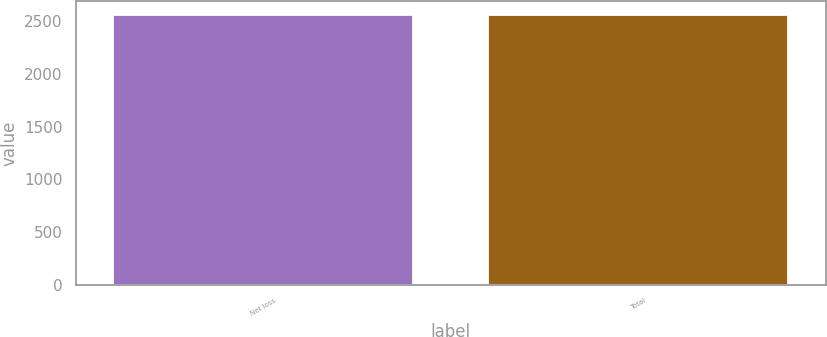<chart> <loc_0><loc_0><loc_500><loc_500><bar_chart><fcel>Net loss<fcel>Total<nl><fcel>2563<fcel>2563.1<nl></chart> 